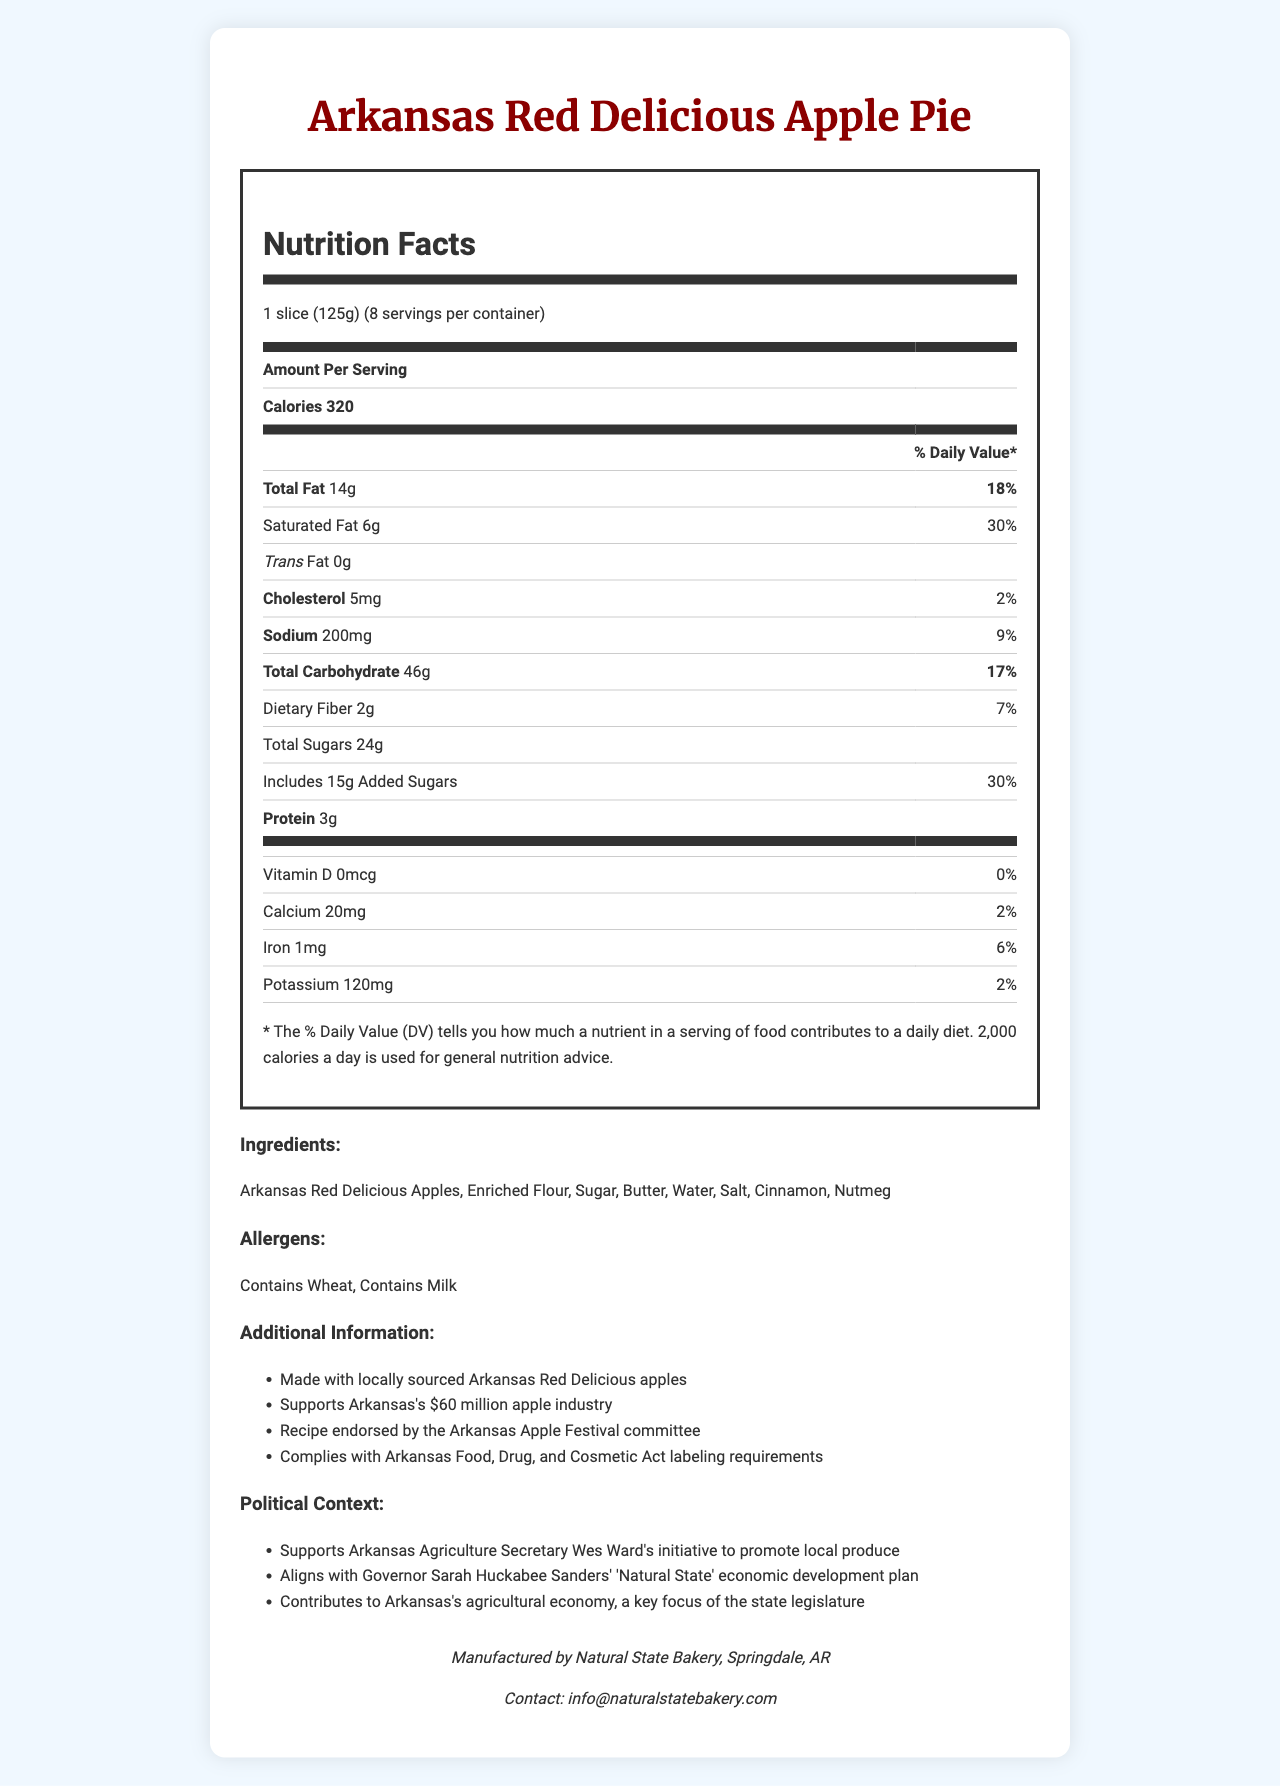what is the serving size? The serving size is explicitly stated as "1 slice (125g)".
Answer: 1 slice (125g) how many servings are in one container? It is stated that there are 8 servings per container.
Answer: 8 how many calories are in each serving? The document mentions that each serving has 320 calories.
Answer: 320 calories what is the total fat content per serving? The total fat per serving is listed as 14 grams.
Answer: 14g how much protein does one serving contain? The document shows that each serving contains 3 grams of protein.
Answer: 3g how much sodium is in one serving of the pie? The sodium content per serving is mentioned as 200 mg.
Answer: 200mg what percentage of the daily value of saturated fat is in one serving? The saturated fat content per serving is 30% of the daily value.
Answer: 30% what are the main ingredients of the Arkansas Red Delicious Apple Pie? The main ingredients are listed as Arkansas Red Delicious Apples, Enriched Flour, Sugar, Butter, Water, Salt, Cinnamon, and Nutmeg.
Answer: Arkansas Red Delicious Apples, Enriched Flour, Sugar, Butter, Water, Salt, Cinnamon, Nutmeg which allergens are present in the product? The allergens are indicated as Wheat and Milk.
Answer: Wheat and Milk how much dietary fiber is in one serving? The amount of dietary fiber per serving is listed as 2 grams.
Answer: 2g how much added sugars are in one serving? A. 10g B. 12g C. 15g D. 20g The document states that the added sugars per serving are 15 grams.
Answer: C. 15g who manufactures the Arkansas Red Delicious Apple Pie? A. Arkansas Orchard B. Natural State Bakery C. Farmer's Fresh Bakery D. Local Honey Bakery It is mentioned that the pie is manufactured by Natural State Bakery.
Answer: B. Natural State Bakery who is the Agriculture Secretary of Arkansas? The document mentions that the initiative to promote local produce is supported by Arkansas Agriculture Secretary Wes Ward.
Answer: Wes Ward does each serving of the pie contain any trans fat? The document clearly states that the pie contains 0 grams of trans fat per serving.
Answer: No does this product support Arkansas's agricultural economy? The political context section mentions that the product contributes to Arkansas's agricultural economy.
Answer: Yes summarize the main idea of the document. The document is visually structured to inform consumers about the nutritional values, ingredients, allergens, additional information regarding economic support for the state's apple industry, political context, and manufacturer details.
Answer: The document provides detailed nutritional information and political context for the Arkansas Red Delicious Apple Pie, highlighting locally sourced ingredients, nutritional contents, allergens, and the economic benefits to Arkansas's agriculture. when was the Arkansas Apple Festival founded? The document does not provide any information about the foundation year of the Arkansas Apple Festival.
Answer: Not enough information 